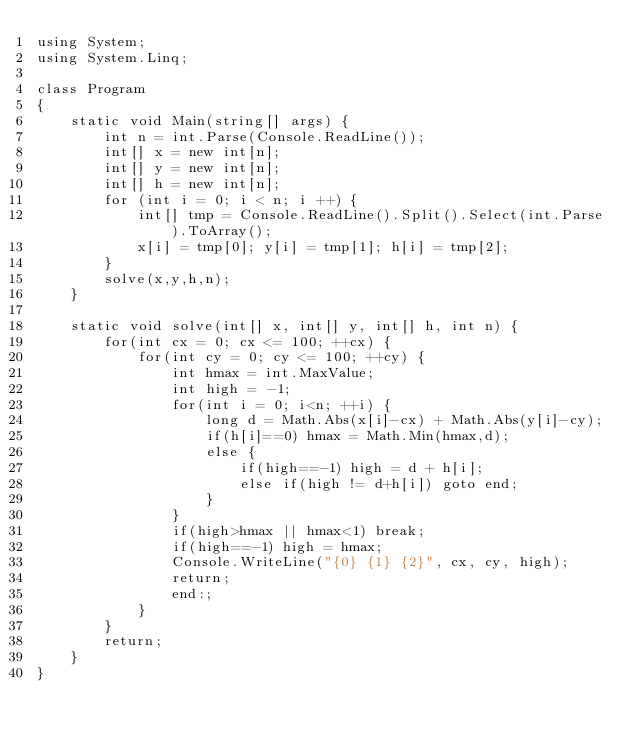<code> <loc_0><loc_0><loc_500><loc_500><_C#_>using System;
using System.Linq;

class Program
{
    static void Main(string[] args) {
        int n = int.Parse(Console.ReadLine());
        int[] x = new int[n];
        int[] y = new int[n];
        int[] h = new int[n];
        for (int i = 0; i < n; i ++) {
            int[] tmp = Console.ReadLine().Split().Select(int.Parse).ToArray();
            x[i] = tmp[0]; y[i] = tmp[1]; h[i] = tmp[2];
        }
        solve(x,y,h,n);
    }

    static void solve(int[] x, int[] y, int[] h, int n) {
        for(int cx = 0; cx <= 100; ++cx) {
            for(int cy = 0; cy <= 100; ++cy) {
                int hmax = int.MaxValue;
                int high = -1;
                for(int i = 0; i<n; ++i) {
                    long d = Math.Abs(x[i]-cx) + Math.Abs(y[i]-cy);
                    if(h[i]==0) hmax = Math.Min(hmax,d);
                    else {
                        if(high==-1) high = d + h[i];
                        else if(high != d+h[i]) goto end;
                    }
                }
                if(high>hmax || hmax<1) break;
                if(high==-1) high = hmax;
                Console.WriteLine("{0} {1} {2}", cx, cy, high);
                return;
                end:;
            }
        }
        return;
    }
}</code> 